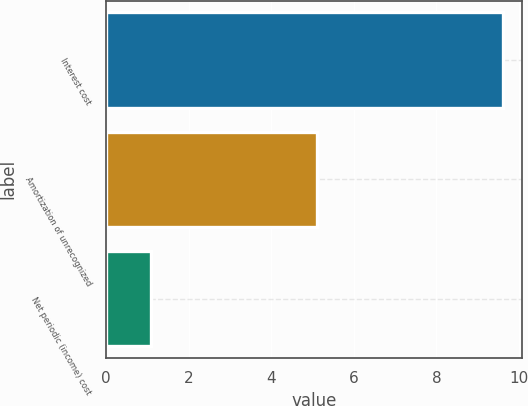Convert chart. <chart><loc_0><loc_0><loc_500><loc_500><bar_chart><fcel>Interest cost<fcel>Amortization of unrecognized<fcel>Net periodic (income) cost<nl><fcel>9.6<fcel>5.1<fcel>1.1<nl></chart> 